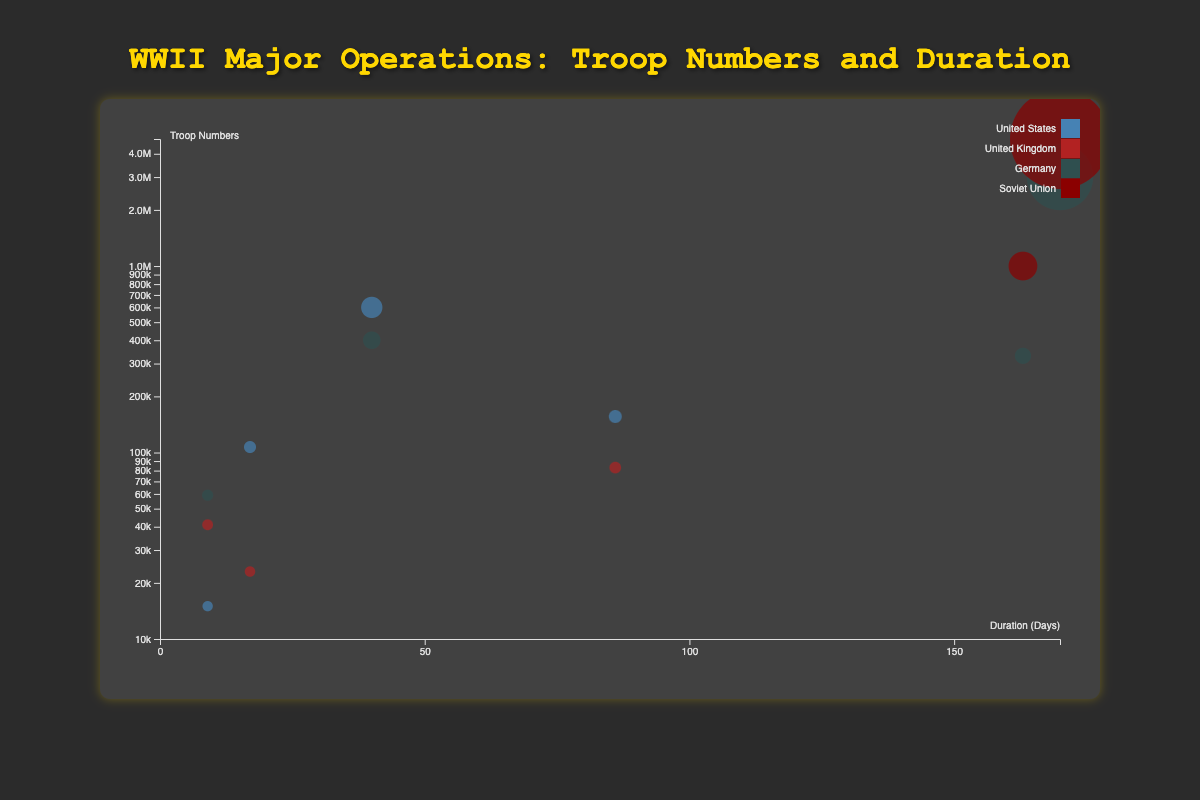What is the title of the figure? The title is displayed at the top of the figure, written in a larger font. It usually summarizes the main topic or content of the figure.
Answer: WWII Major Operations: Troop Numbers and Duration Which country had the highest troop numbers in Operation Barbarossa? Locate the data points for Operation Barbarossa on the chart and compare the troop numbers for each country involved. The Soviet Union's bubble is the largest, indicating the highest troop numbers.
Answer: Soviet Union Which operation had the shortest duration and how long did it last? Find the smallest value on the x-axis (duration in days) and check which operation it corresponds to. Operation Market Garden has the shortest duration.
Answer: Operation Market Garden with 9 days How many countries are represented in the bubble chart? The legend lists all the unique countries involved in the operations, represented by different colors. Count these entries.
Answer: 4 countries Compare the troop numbers for the United States in Operation Overlord and Operation Torch. Which operation had more troops? Identify the bubbles for the United States in both operations and compare their sizes. The bubble for Operation Overlord is larger.
Answer: Operation Overlord What is the total troop number for Germany across all represented operations? Sum the troop numbers for Germany in all operations: Barbarossa (3,000,000) + Battle of the Bulge (400,000) + Battle of Stalingrad (330,000) + Operation Market Garden (59,000). The total is 3,789,000.
Answer: 3,789,000 Which country had more troops in the Battle of the Bulge? Look at the bubbles corresponding to the Battle of the Bulge and compare their sizes for each country involved. The United States had more troops.
Answer: United States What is the average duration of the operations involving the United States? Calculate the average duration by summing the durations of all operations involving the United States and dividing by the number of these operations. (86 days for Overlord + 17 days for Torch + 40 days for Battle of the Bulge + 9 days for Market Garden) / 4 operations = 38 days.
Answer: 38 days Which operation had the second longest duration and which countries were involved? Rank the operations by duration and identify the second longest. Operation Stalingrad (163 days) comes after Barbarossa (170 days), involving Germany and the Soviet Union.
Answer: Battle of Stalingrad, Germany and Soviet Union 